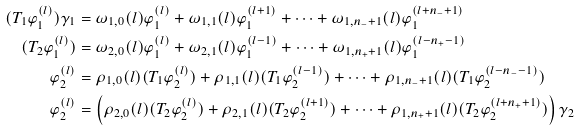Convert formula to latex. <formula><loc_0><loc_0><loc_500><loc_500>( T _ { 1 } \varphi _ { 1 } ^ { ( l ) } ) \gamma _ { 1 } & = \omega _ { 1 , 0 } ( l ) \varphi _ { 1 } ^ { ( l ) } + \omega _ { 1 , 1 } ( l ) \varphi _ { 1 } ^ { ( l + 1 ) } + \cdots + \omega _ { 1 , n _ { - } + 1 } ( l ) \varphi _ { 1 } ^ { ( l + n _ { - } + 1 ) } \\ ( T _ { 2 } \varphi _ { 1 } ^ { ( l ) } ) & = \omega _ { 2 , 0 } ( l ) \varphi _ { 1 } ^ { ( l ) } + \omega _ { 2 , 1 } ( l ) \varphi _ { 1 } ^ { ( l - 1 ) } + \cdots + \omega _ { 1 , n _ { + } + 1 } ( l ) \varphi _ { 1 } ^ { ( l - n _ { + } - 1 ) } \\ \varphi _ { 2 } ^ { ( l ) } & = \rho _ { 1 , 0 } ( l ) ( T _ { 1 } \varphi _ { 2 } ^ { ( l ) } ) + \rho _ { 1 , 1 } ( l ) ( T _ { 1 } \varphi _ { 2 } ^ { ( l - 1 ) } ) + \cdots + \rho _ { 1 , n _ { - } + 1 } ( l ) ( T _ { 1 } \varphi _ { 2 } ^ { ( l - n _ { - } - 1 ) } ) \\ \varphi _ { 2 } ^ { ( l ) } & = \left ( \rho _ { 2 , 0 } ( l ) ( T _ { 2 } \varphi _ { 2 } ^ { ( l ) } ) + \rho _ { 2 , 1 } ( l ) ( T _ { 2 } \varphi _ { 2 } ^ { ( l + 1 ) } ) + \cdots + \rho _ { 1 , n _ { + } + 1 } ( l ) ( T _ { 2 } \varphi _ { 2 } ^ { ( l + n _ { + } + 1 ) } ) \right ) \gamma _ { 2 }</formula> 